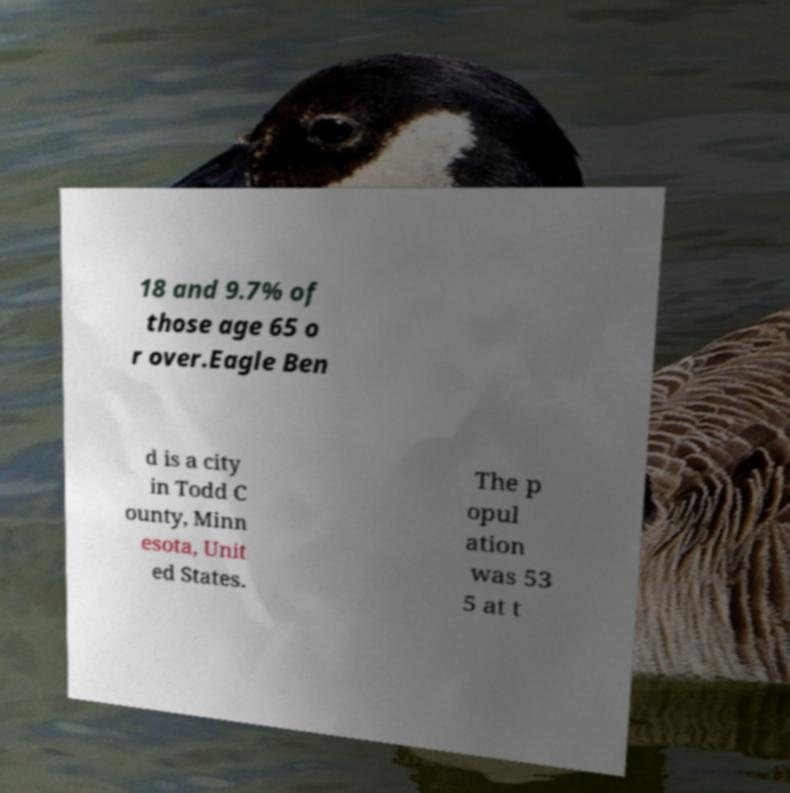Can you accurately transcribe the text from the provided image for me? 18 and 9.7% of those age 65 o r over.Eagle Ben d is a city in Todd C ounty, Minn esota, Unit ed States. The p opul ation was 53 5 at t 